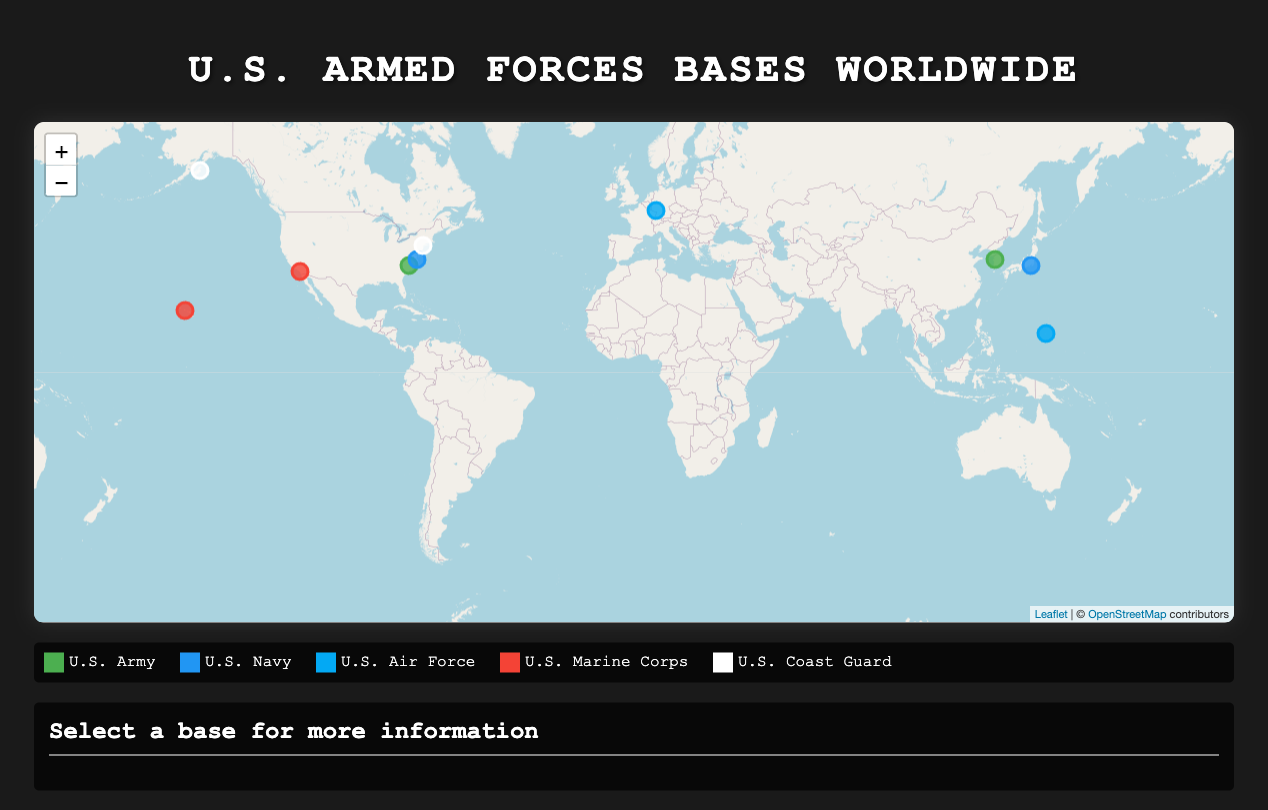what is the location of Fort Bragg? Fort Bragg is located in North Carolina, USA, as stated in the base information.
Answer: North Carolina, USA how many personnel are stationed at Naval Station Norfolk? The number of personnel stationed at Naval Station Norfolk is mentioned in the data as 67000.
Answer: 67000 name a unit stationed at Camp Pendleton. The types of units stationed at Camp Pendleton include the I Marine Expeditionary Force and the 1st Marine Division.
Answer: I Marine Expeditionary Force which branch has the base with the most personnel? By comparing the number of personnel at each base, Naval Station Norfolk has the most at 67000, which belongs to the U.S. Navy.
Answer: U.S. Navy how many bases are located in Japan? There are two bases mentioned that are located in Japan, including Naval Base Yokosuka only.
Answer: 1 why is the U.S. Coast Guard Base Kodiak significant? The U.S. Coast Guard Base Kodiak is significant because it is one of the few bases in Alaska and has a personnel count of 3000.
Answer: 3000 what color represents the U.S. Air Force on the map? The U.S. Air Force is represented by the color Light Blue on the legend included in the document.
Answer: Light Blue which branch has a base in South Korea? The document specifies that the U.S. Army has a base located in South Korea, specifically Camp Humphreys.
Answer: U.S. Army 